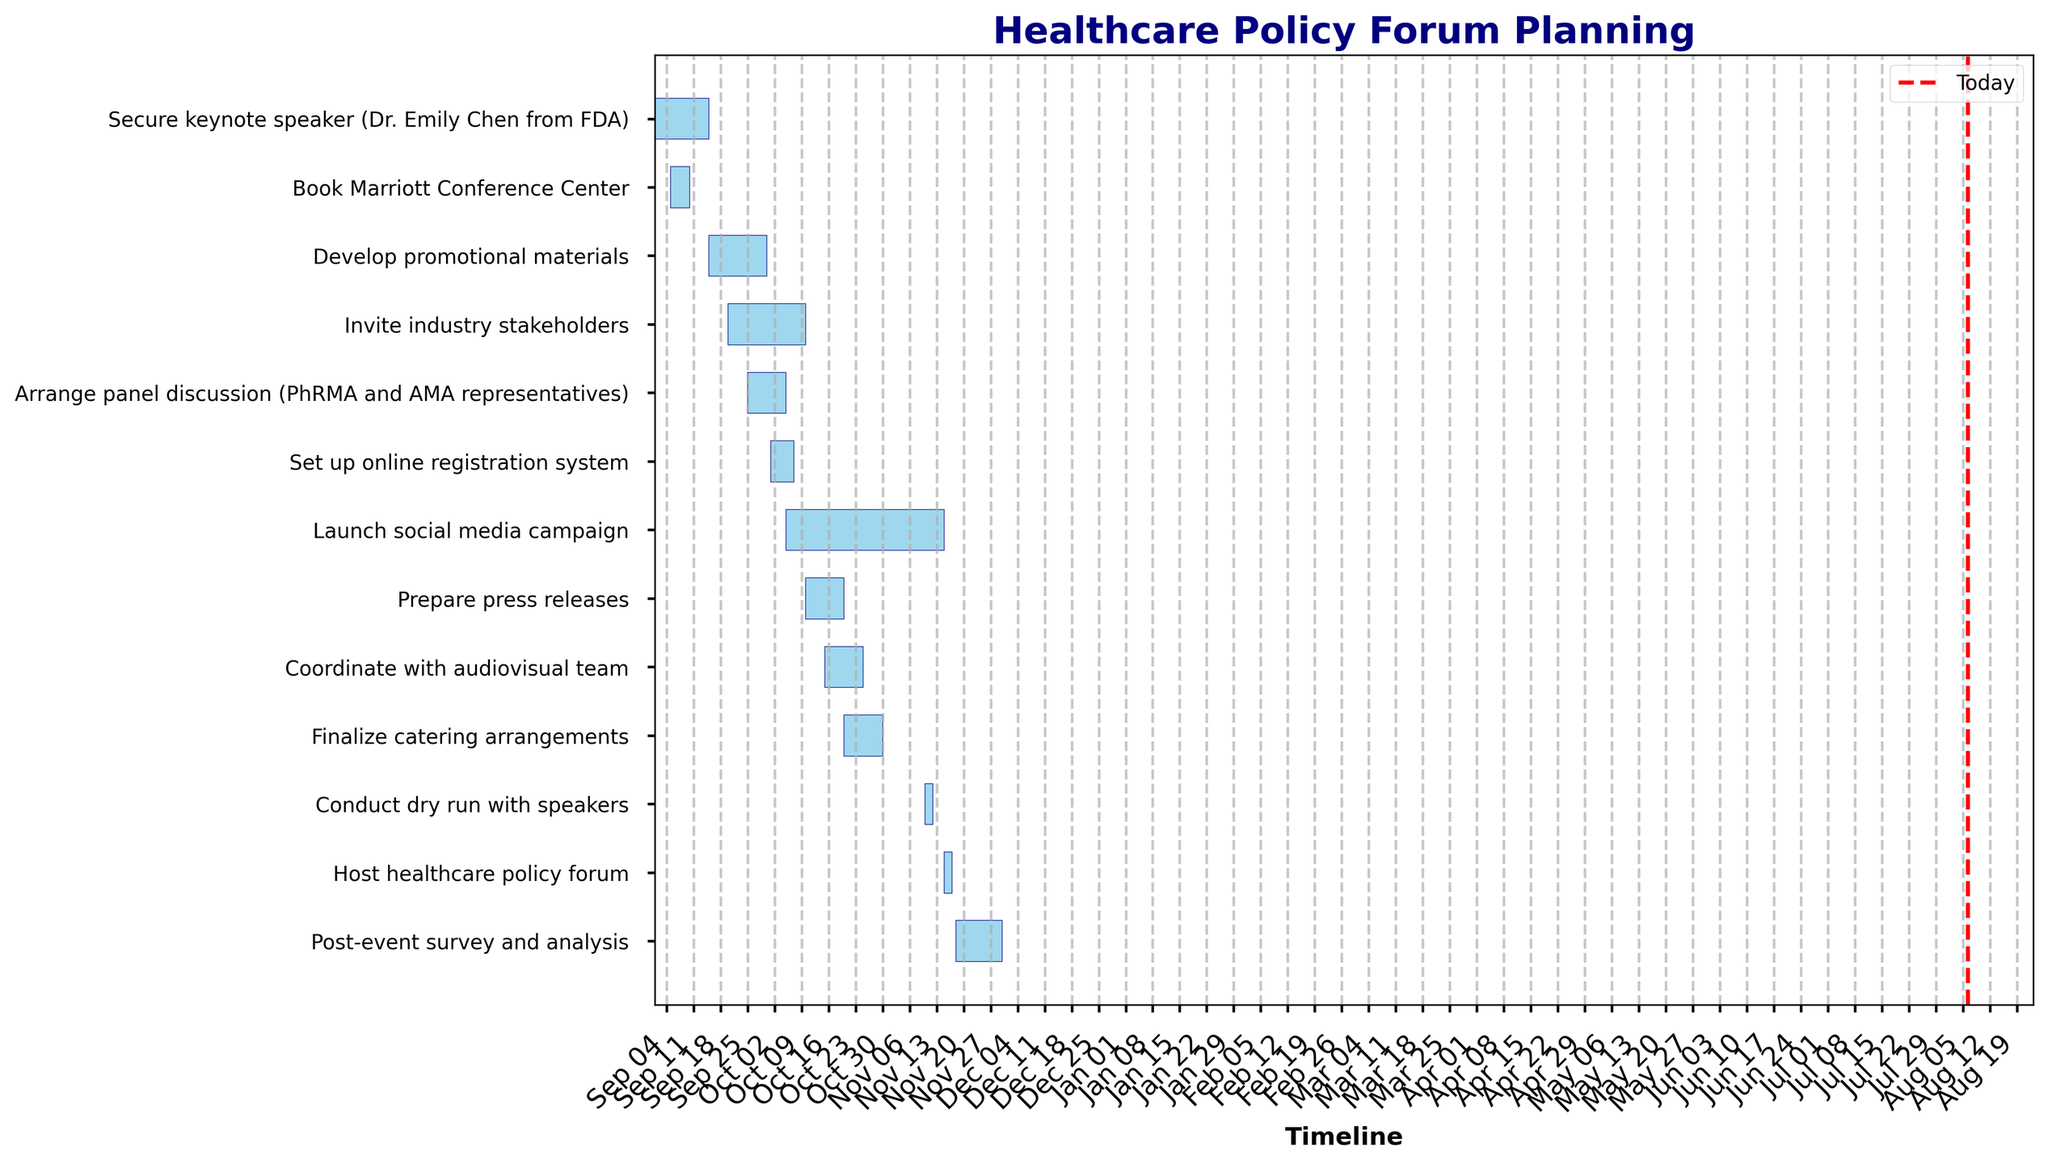What is the title of the Gantt Chart? The title of the chart is usually displayed at the top and provides a clear indication of the topic of the chart. Here, the title is "Healthcare Policy Forum Planning."
Answer: Healthcare Policy Forum Planning How long is the task 'Develop promotional materials'? To find the duration of a task, subtract the start date from the end date. The task 'Develop promotional materials' starts on 2023-09-15 and ends on 2023-09-30. The duration is thus 30 - 15 = 15 days.
Answer: 15 days Which task ends immediately before 'Launch social media campaign'? Look at the ending dates of tasks directly above 'Launch social media campaign' in the chart. 'Set up online registration system' completes immediately before the campaign starts.
Answer: Set up online registration system On what date does 'Host healthcare policy forum' start? The start date of each task is indicated next to the bars. 'Host healthcare policy forum' starts on 2023-11-15.
Answer: 2023-11-15 Which tasks overlap with 'Invite industry stakeholders'? Overlapping tasks have bars that visually intersect. Tasks 'Develop promotional materials', 'Arrange panel discussion', 'Set up online registration system', and 'Invite industry stakeholders' all overlap.
Answer: Develop promotional materials, Arrange panel discussion, Set up online registration system How many tasks are scheduled to continue after 'Host healthcare policy forum' begins? 'Host healthcare policy forum' begins on 2023-11-15. Any task bar extending beyond this date counts. Only 'Post-event survey and analysis' continues beyond this date.
Answer: 1 task What is the total duration from the start of 'Secure keynote speaker' to the end of 'Post-event survey and analysis'? The total duration is calculated by subtracting the start date of the first task from the end date of the last task. The timeline from 2023-09-01 to 2023-11-30 includes September, October, November, summing up to 92 days.
Answer: 92 days Which task takes the longest to complete? Compare the lengths of the bars. 'Launch social media campaign' spans the longest time from 2023-10-05 to 2023-11-15, totaling 41 days.
Answer: Launch social media campaign What tasks are scheduled for October 15? Tasks active on October 15 have bars covering this date. These are 'Invite industry stakeholders', 'Arrange panel discussion', 'Set up online registration system', and 'Coordinate with audiovisual team'.
Answer: Invite industry stakeholders, Arrange panel discussion, Set up online registration system, Coordinate with audiovisual team 